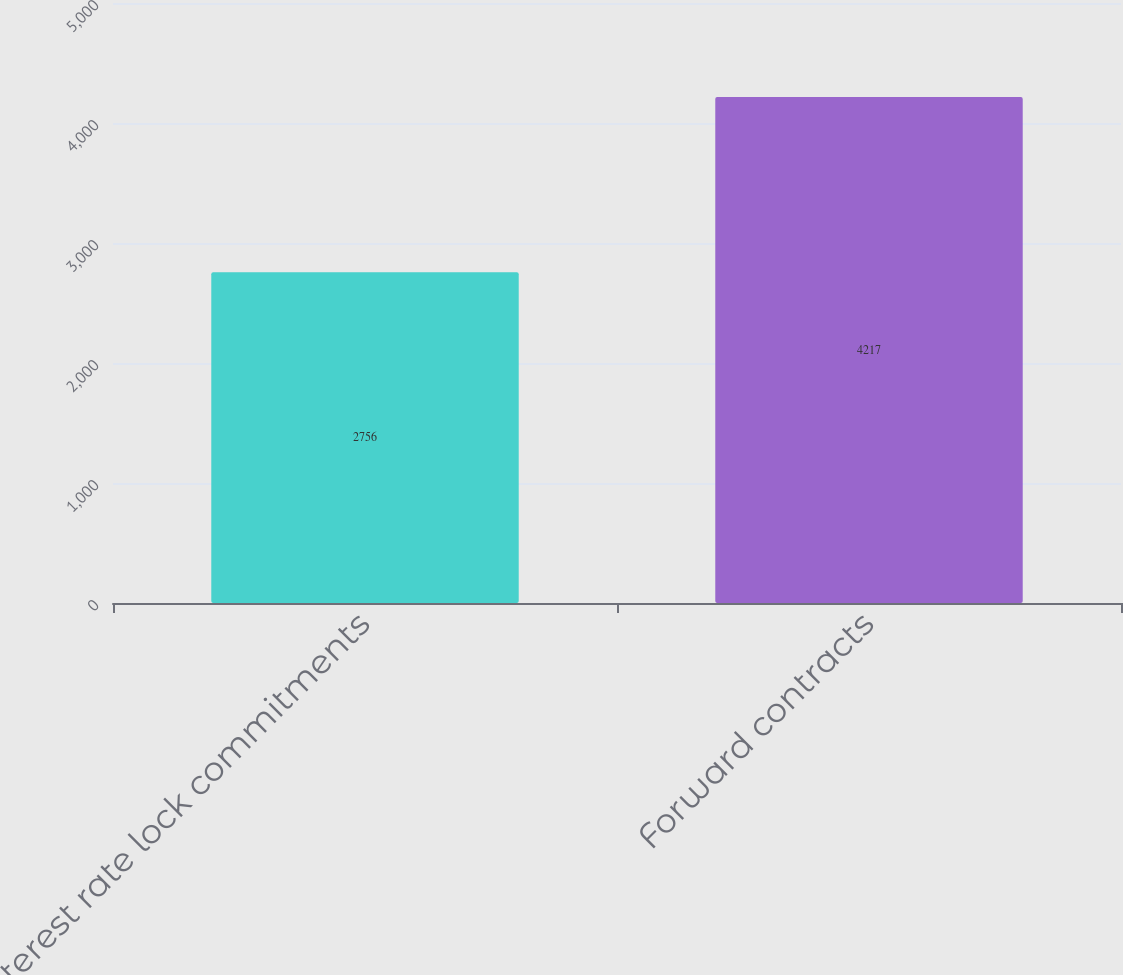Convert chart. <chart><loc_0><loc_0><loc_500><loc_500><bar_chart><fcel>Interest rate lock commitments<fcel>Forward contracts<nl><fcel>2756<fcel>4217<nl></chart> 